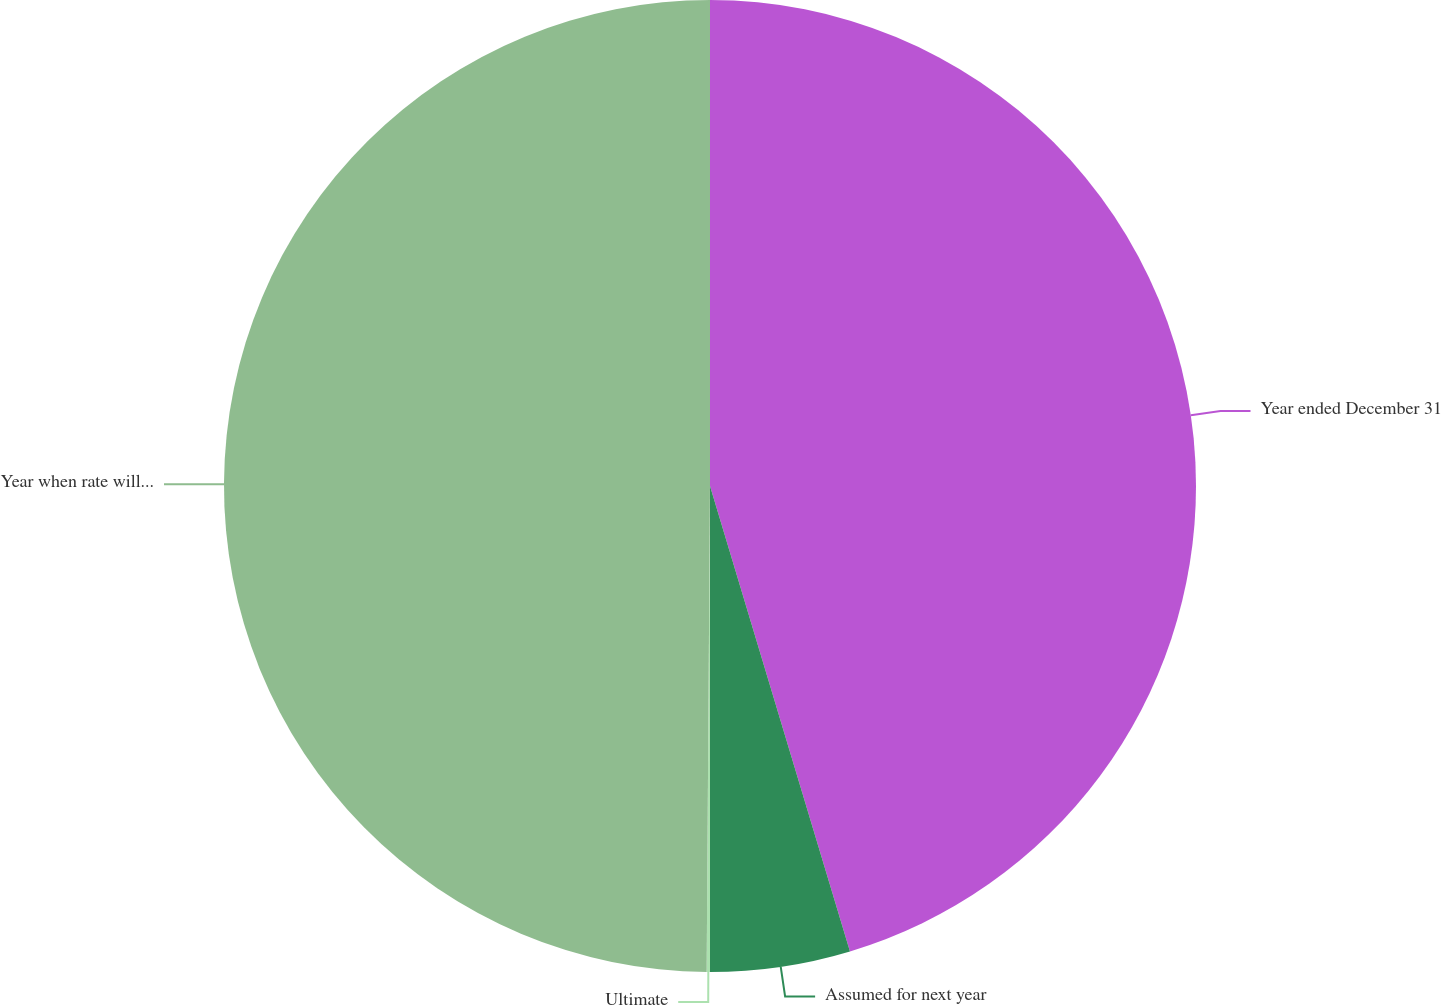<chart> <loc_0><loc_0><loc_500><loc_500><pie_chart><fcel>Year ended December 31<fcel>Assumed for next year<fcel>Ultimate<fcel>Year when rate will reach<nl><fcel>45.35%<fcel>4.65%<fcel>0.11%<fcel>49.89%<nl></chart> 